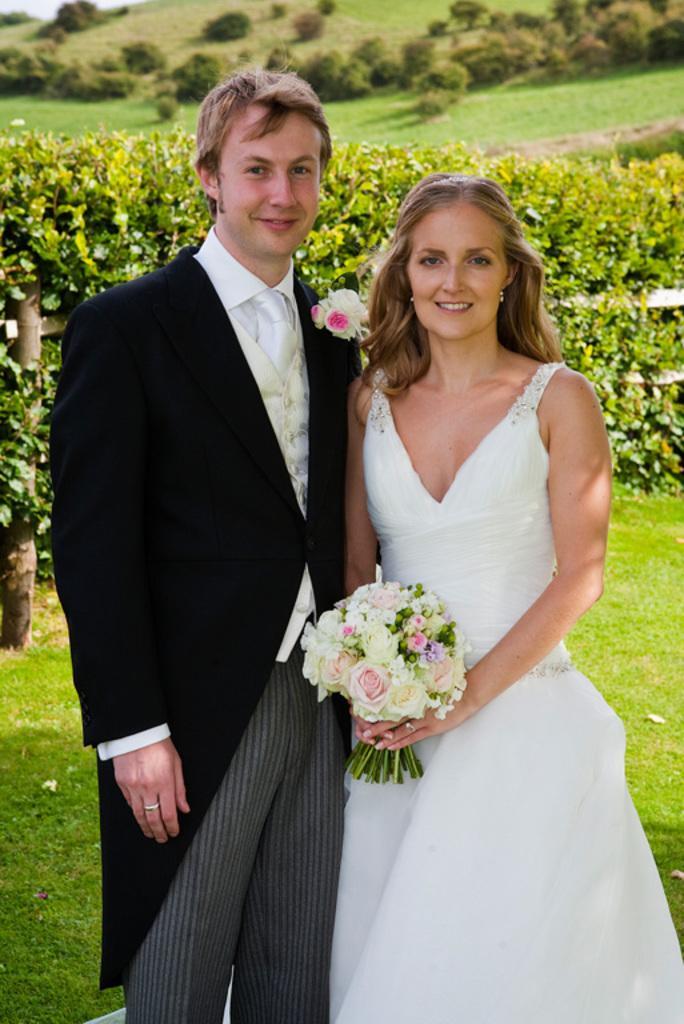How would you summarize this image in a sentence or two? In the picture we can see a man and a woman standing seems like they are married, a woman is wearing a white dress and holding a flower bookey and the man is wearing a blazer with tie and shirt and in the background we can see a grass surface and plants. 